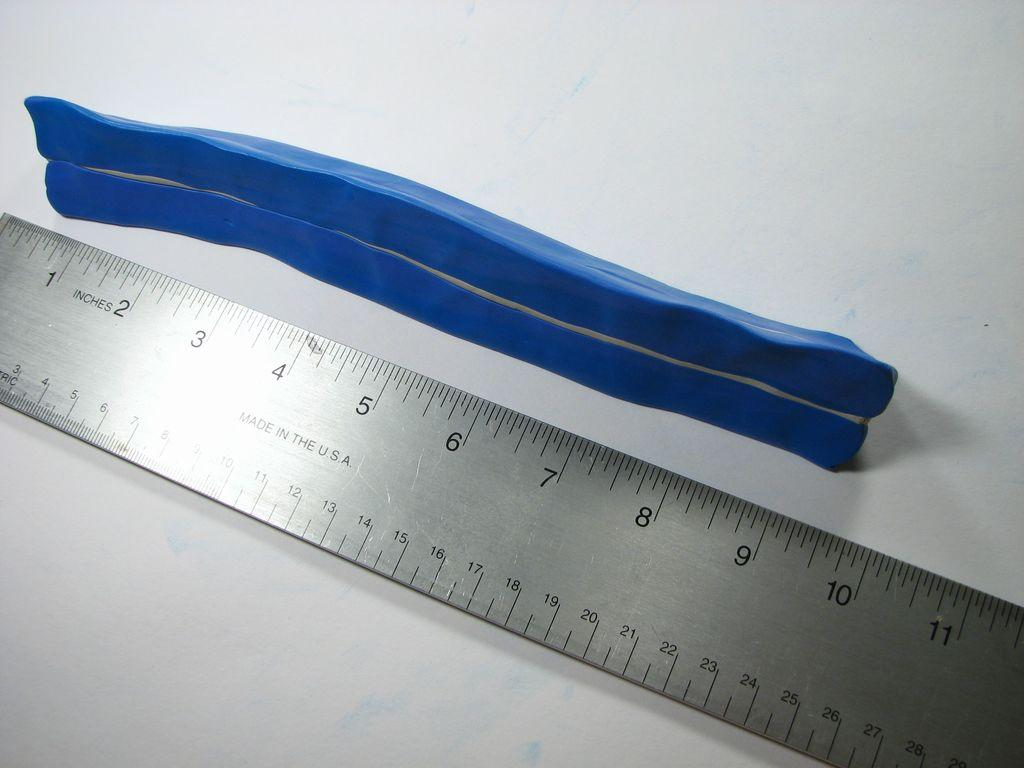What type of weighing instrument is present in the image? There is a metal scale in the image. What color is one of the objects in the image? There is a blue color object in the image. What is the color of the surface on which the objects are placed? The objects are placed on a white color surface. Can you see a hook attached to the queen in the image? There is no hook or queen present in the image. 